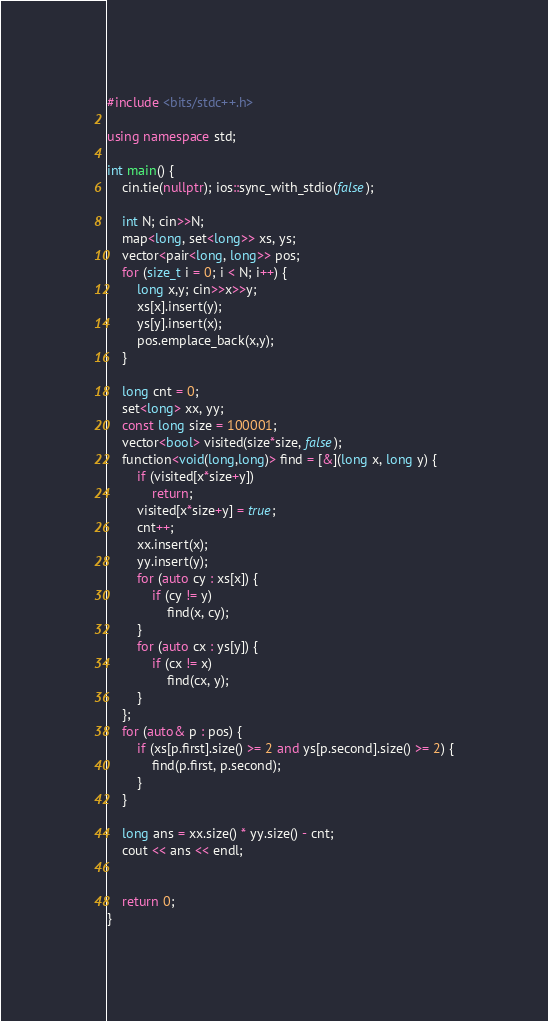<code> <loc_0><loc_0><loc_500><loc_500><_C++_>#include <bits/stdc++.h>

using namespace std;

int main() {
    cin.tie(nullptr); ios::sync_with_stdio(false);

    int N; cin>>N;
    map<long, set<long>> xs, ys;
    vector<pair<long, long>> pos;
    for (size_t i = 0; i < N; i++) {
        long x,y; cin>>x>>y;
        xs[x].insert(y);
        ys[y].insert(x);
        pos.emplace_back(x,y);
    }

    long cnt = 0;
    set<long> xx, yy;
    const long size = 100001;
    vector<bool> visited(size*size, false);
    function<void(long,long)> find = [&](long x, long y) {
        if (visited[x*size+y])
            return;
        visited[x*size+y] = true;
        cnt++;
        xx.insert(x);
        yy.insert(y);
        for (auto cy : xs[x]) {
            if (cy != y)
                find(x, cy);
        }
        for (auto cx : ys[y]) {
            if (cx != x)
                find(cx, y);
        }
    };
    for (auto& p : pos) {
        if (xs[p.first].size() >= 2 and ys[p.second].size() >= 2) {
            find(p.first, p.second);
        }
    }

    long ans = xx.size() * yy.size() - cnt;
    cout << ans << endl;


    return 0;
}
</code> 